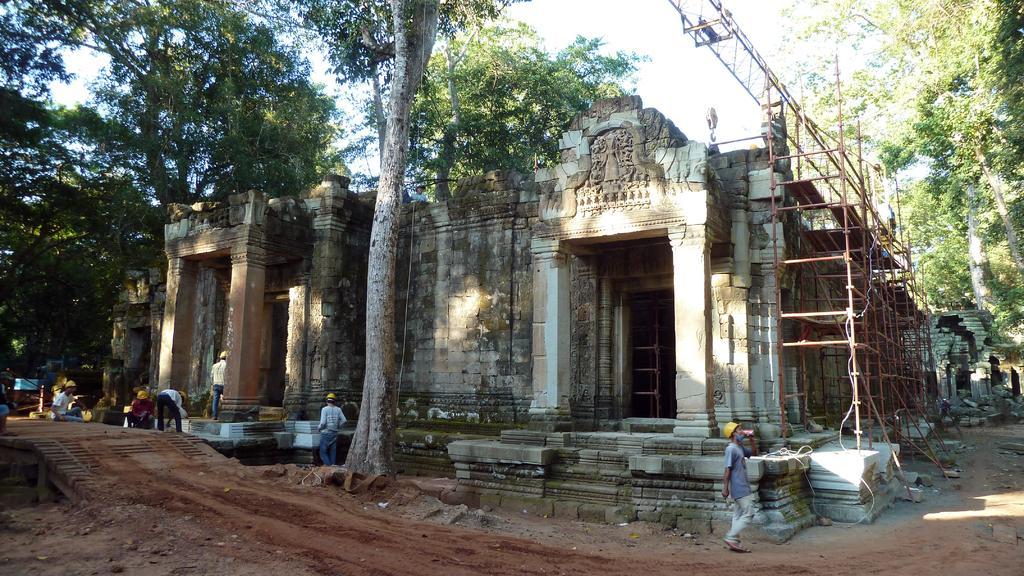Describe this image in one or two sentences. In this image there is a building and we can see rods. At the bottom there are people wearing helmets. In the background there are trees and sky. 